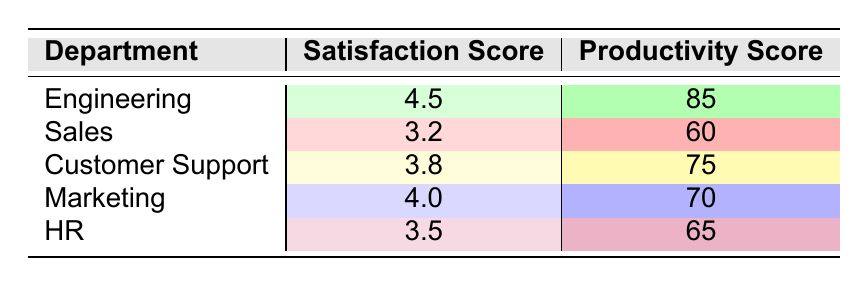What is the satisfaction score for the Engineering department? The table lists the satisfaction scores by department. For Engineering, the satisfaction score is explicitly shown as 4.5.
Answer: 4.5 What is the productivity score for the Sales department? The table provides the productivity scores for each department. For Sales, the productivity score is indicated as 60.
Answer: 60 Which department has the highest satisfaction score? By examining the satisfaction scores in the table, Engineering has the highest score at 4.5.
Answer: Engineering What is the average satisfaction score across all departments? To find the average satisfaction score, sum the satisfaction scores: (4.5 + 3.2 + 3.8 + 4.0 + 3.5) = 18. The average is 18 divided by 5, which is 3.6.
Answer: 3.6 Is the productivity score of the Marketing department higher than that of Customer Support? According to the table, Marketing has a productivity score of 70 and Customer Support has 75. Since 70 is less than 75, the answer is no.
Answer: No Which department has a satisfaction score lower than 4.0? Checking the table, the departments with satisfaction scores below 4.0 are Sales (3.2), Customer Support (3.8), and HR (3.5).
Answer: Sales, Customer Support, HR What is the difference in productivity scores between the Engineering and HR departments? The productivity score for Engineering is 85, and for HR, it is 65. The difference is 85 - 65 = 20.
Answer: 20 Is there a department where both satisfaction and productivity scores are above 4.0 and 80 respectively? Looking at the table, only Engineering has a satisfaction score of 4.5 and a productivity score of 85, meeting both criteria.
Answer: Yes Which department shows the lowest satisfaction score? By examining the satisfaction scores in the table, Sales has the lowest score at 3.2.
Answer: Sales 